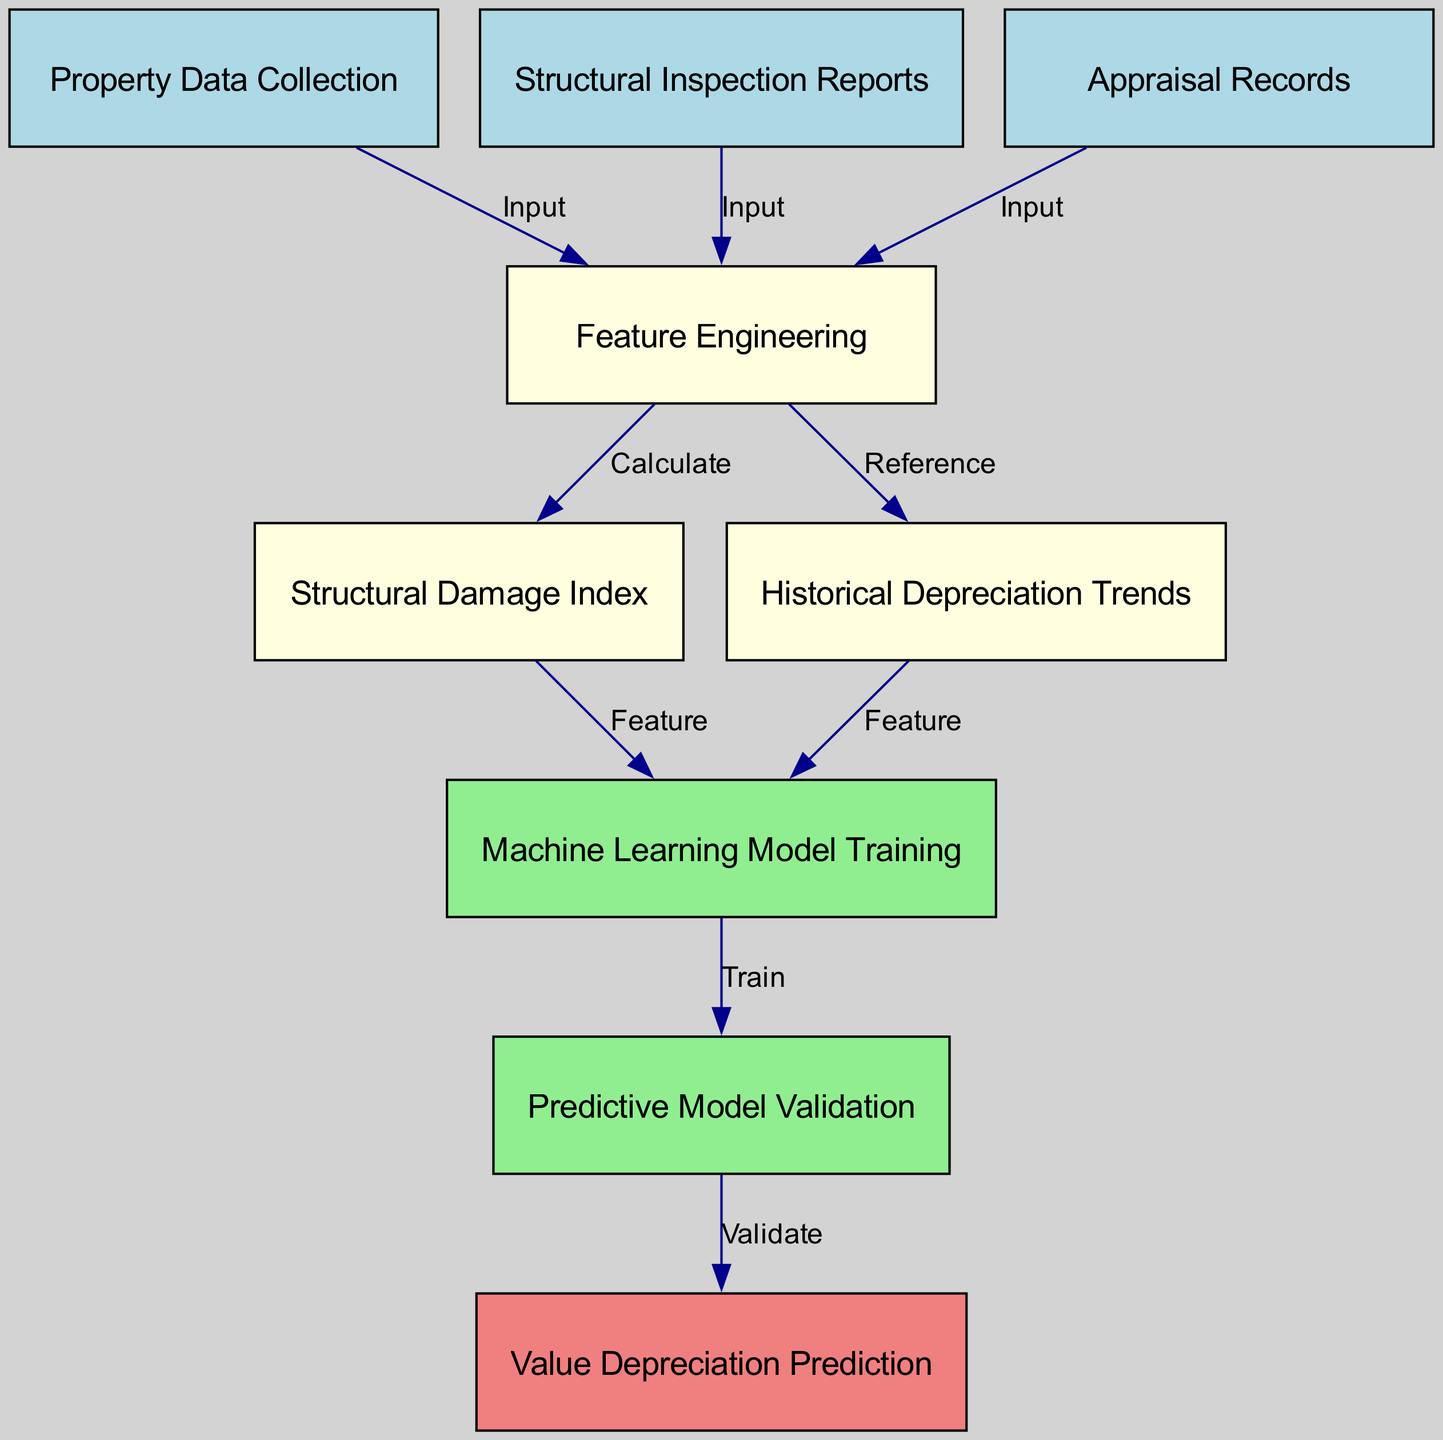What are the input nodes in the diagram? The diagram has three input nodes: "Property Data Collection," "Structural Inspection Reports," and "Appraisal Records" which provide the necessary data for further processing.
Answer: Property Data Collection, Structural Inspection Reports, Appraisal Records How many edges are in the diagram? The diagram contains a total of eight edges that connect various nodes to represent the flow of information.
Answer: Eight What is the output of the "Predictive Model Validation" node? The "Predictive Model Validation" node outputs the result to the "Value Depreciation Prediction" node, which indicates the final prediction based on the validation process.
Answer: Value Depreciation Prediction Which nodes provide input for "Feature Engineering"? The input nodes for "Feature Engineering" are "Property Data Collection," "Structural Inspection Reports," and "Appraisal Records," indicating that these sources are combined to engineer features for the model.
Answer: Property Data Collection, Structural Inspection Reports, Appraisal Records What is the function of the "Structural Damage Index" node? The "Structural Damage Index" node calculates a value based on the features created in "Feature Engineering" to quantify the extent of structural damage impacting property value.
Answer: Calculate How do the "Historical Depreciation Trends" contribute to the model? The "Historical Depreciation Trends" serve as a reference for feature engineering, allowing the model to utilize past patterns to predict future depreciation based on structural issues.
Answer: Reference Which node is responsible for training the machine learning model? The "Machine Learning Model Training" node is designated as responsible for training the model using the features derived from both the "Structural Damage Index" and "Historical Depreciation Trends."
Answer: Machine Learning Model Training What color represents the nodes related to input data? In the diagram, nodes related to input data are represented in light blue color, visually distinguishing them from other nodes in the process.
Answer: Light blue What is the role of the "Predictive Model Validation"? The role of "Predictive Model Validation" is to assess the trained machine learning model to ensure its predictions regarding property value depreciation are accurate before generating outputs.
Answer: Validate 